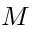<formula> <loc_0><loc_0><loc_500><loc_500>M</formula> 